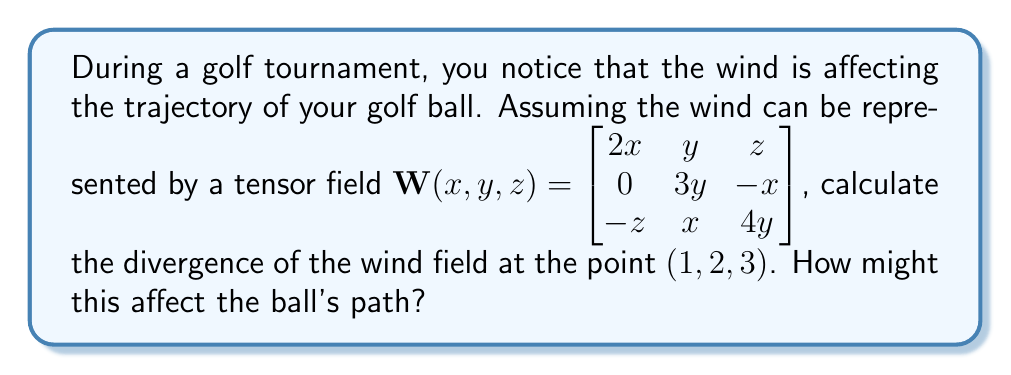Could you help me with this problem? To solve this problem, we'll follow these steps:

1) The divergence of a tensor field $\mathbf{W}(x, y, z)$ is given by:

   $$\nabla \cdot \mathbf{W} = \frac{\partial W_{11}}{\partial x} + \frac{\partial W_{22}}{\partial y} + \frac{\partial W_{33}}{\partial z}$$

2) From the given tensor field:
   $W_{11} = 2x$
   $W_{22} = 3y$
   $W_{33} = 4y$

3) Calculate the partial derivatives:
   $\frac{\partial W_{11}}{\partial x} = 2$
   $\frac{\partial W_{22}}{\partial y} = 3$
   $\frac{\partial W_{33}}{\partial z} = 0$

4) Sum the partial derivatives:
   $$\nabla \cdot \mathbf{W} = 2 + 3 + 0 = 5$$

5) This result is constant and doesn't depend on the point, so it's the same at $(1, 2, 3)$.

6) Interpretation: A positive divergence indicates that the wind field is expanding or spreading out at this point. This could cause the golf ball to experience additional lift or drag, potentially altering its trajectory. The ball might travel further if the wind is in the same direction as its path, or it might be pushed off course if the wind is perpendicular to its trajectory.
Answer: 5; The positive divergence indicates wind expansion, potentially increasing lift or altering the ball's trajectory. 